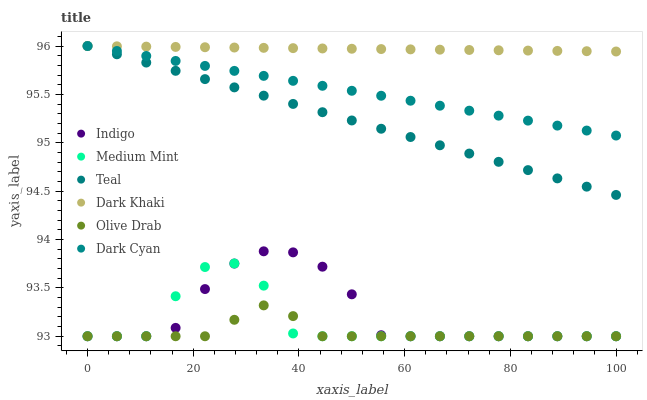Does Olive Drab have the minimum area under the curve?
Answer yes or no. Yes. Does Dark Khaki have the maximum area under the curve?
Answer yes or no. Yes. Does Indigo have the minimum area under the curve?
Answer yes or no. No. Does Indigo have the maximum area under the curve?
Answer yes or no. No. Is Dark Khaki the smoothest?
Answer yes or no. Yes. Is Medium Mint the roughest?
Answer yes or no. Yes. Is Indigo the smoothest?
Answer yes or no. No. Is Indigo the roughest?
Answer yes or no. No. Does Medium Mint have the lowest value?
Answer yes or no. Yes. Does Dark Khaki have the lowest value?
Answer yes or no. No. Does Dark Cyan have the highest value?
Answer yes or no. Yes. Does Indigo have the highest value?
Answer yes or no. No. Is Olive Drab less than Teal?
Answer yes or no. Yes. Is Dark Khaki greater than Olive Drab?
Answer yes or no. Yes. Does Dark Cyan intersect Teal?
Answer yes or no. Yes. Is Dark Cyan less than Teal?
Answer yes or no. No. Is Dark Cyan greater than Teal?
Answer yes or no. No. Does Olive Drab intersect Teal?
Answer yes or no. No. 